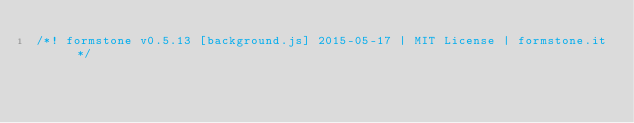<code> <loc_0><loc_0><loc_500><loc_500><_JavaScript_>/*! formstone v0.5.13 [background.js] 2015-05-17 | MIT License | formstone.it */
</code> 